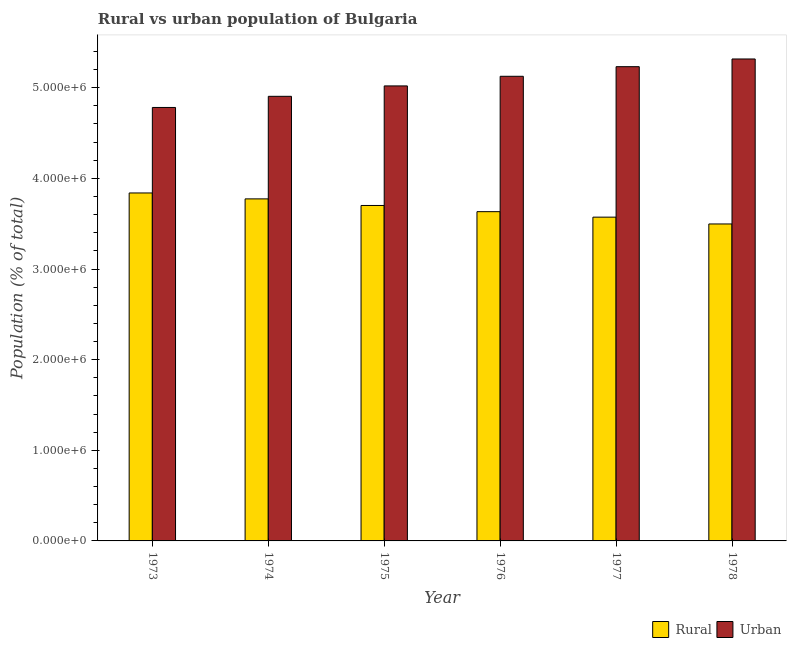How many different coloured bars are there?
Offer a terse response. 2. How many groups of bars are there?
Your answer should be compact. 6. Are the number of bars on each tick of the X-axis equal?
Provide a short and direct response. Yes. How many bars are there on the 6th tick from the left?
Give a very brief answer. 2. How many bars are there on the 2nd tick from the right?
Offer a very short reply. 2. What is the label of the 4th group of bars from the left?
Your answer should be compact. 1976. In how many cases, is the number of bars for a given year not equal to the number of legend labels?
Make the answer very short. 0. What is the urban population density in 1975?
Provide a short and direct response. 5.02e+06. Across all years, what is the maximum urban population density?
Offer a terse response. 5.32e+06. Across all years, what is the minimum urban population density?
Offer a very short reply. 4.78e+06. In which year was the urban population density maximum?
Your answer should be very brief. 1978. In which year was the rural population density minimum?
Your answer should be compact. 1978. What is the total rural population density in the graph?
Keep it short and to the point. 2.20e+07. What is the difference between the rural population density in 1974 and that in 1977?
Offer a terse response. 2.02e+05. What is the difference between the urban population density in 1977 and the rural population density in 1978?
Offer a terse response. -8.50e+04. What is the average urban population density per year?
Your answer should be very brief. 5.06e+06. In the year 1975, what is the difference between the urban population density and rural population density?
Your answer should be compact. 0. What is the ratio of the rural population density in 1975 to that in 1976?
Make the answer very short. 1.02. Is the urban population density in 1977 less than that in 1978?
Your answer should be compact. Yes. Is the difference between the rural population density in 1973 and 1974 greater than the difference between the urban population density in 1973 and 1974?
Provide a succinct answer. No. What is the difference between the highest and the second highest urban population density?
Give a very brief answer. 8.50e+04. What is the difference between the highest and the lowest urban population density?
Your answer should be compact. 5.35e+05. In how many years, is the urban population density greater than the average urban population density taken over all years?
Make the answer very short. 3. Is the sum of the urban population density in 1977 and 1978 greater than the maximum rural population density across all years?
Make the answer very short. Yes. What does the 2nd bar from the left in 1974 represents?
Ensure brevity in your answer.  Urban. What does the 1st bar from the right in 1977 represents?
Your response must be concise. Urban. Are all the bars in the graph horizontal?
Offer a very short reply. No. How many years are there in the graph?
Ensure brevity in your answer.  6. Are the values on the major ticks of Y-axis written in scientific E-notation?
Keep it short and to the point. Yes. Does the graph contain grids?
Give a very brief answer. No. How many legend labels are there?
Provide a short and direct response. 2. What is the title of the graph?
Make the answer very short. Rural vs urban population of Bulgaria. Does "Male entrants" appear as one of the legend labels in the graph?
Keep it short and to the point. No. What is the label or title of the X-axis?
Offer a very short reply. Year. What is the label or title of the Y-axis?
Your answer should be compact. Population (% of total). What is the Population (% of total) of Rural in 1973?
Ensure brevity in your answer.  3.84e+06. What is the Population (% of total) in Urban in 1973?
Offer a terse response. 4.78e+06. What is the Population (% of total) in Rural in 1974?
Your answer should be very brief. 3.77e+06. What is the Population (% of total) in Urban in 1974?
Your response must be concise. 4.91e+06. What is the Population (% of total) in Rural in 1975?
Give a very brief answer. 3.70e+06. What is the Population (% of total) of Urban in 1975?
Provide a succinct answer. 5.02e+06. What is the Population (% of total) in Rural in 1976?
Give a very brief answer. 3.63e+06. What is the Population (% of total) in Urban in 1976?
Your answer should be compact. 5.13e+06. What is the Population (% of total) of Rural in 1977?
Give a very brief answer. 3.57e+06. What is the Population (% of total) of Urban in 1977?
Offer a terse response. 5.23e+06. What is the Population (% of total) of Rural in 1978?
Make the answer very short. 3.50e+06. What is the Population (% of total) in Urban in 1978?
Ensure brevity in your answer.  5.32e+06. Across all years, what is the maximum Population (% of total) of Rural?
Make the answer very short. 3.84e+06. Across all years, what is the maximum Population (% of total) of Urban?
Offer a terse response. 5.32e+06. Across all years, what is the minimum Population (% of total) of Rural?
Provide a short and direct response. 3.50e+06. Across all years, what is the minimum Population (% of total) in Urban?
Provide a succinct answer. 4.78e+06. What is the total Population (% of total) of Rural in the graph?
Offer a terse response. 2.20e+07. What is the total Population (% of total) of Urban in the graph?
Your response must be concise. 3.04e+07. What is the difference between the Population (% of total) in Rural in 1973 and that in 1974?
Offer a terse response. 6.52e+04. What is the difference between the Population (% of total) of Urban in 1973 and that in 1974?
Your answer should be compact. -1.23e+05. What is the difference between the Population (% of total) of Rural in 1973 and that in 1975?
Your response must be concise. 1.38e+05. What is the difference between the Population (% of total) of Urban in 1973 and that in 1975?
Offer a terse response. -2.38e+05. What is the difference between the Population (% of total) in Rural in 1973 and that in 1976?
Your answer should be compact. 2.06e+05. What is the difference between the Population (% of total) of Urban in 1973 and that in 1976?
Your answer should be very brief. -3.44e+05. What is the difference between the Population (% of total) of Rural in 1973 and that in 1977?
Make the answer very short. 2.67e+05. What is the difference between the Population (% of total) in Urban in 1973 and that in 1977?
Keep it short and to the point. -4.50e+05. What is the difference between the Population (% of total) in Rural in 1973 and that in 1978?
Provide a succinct answer. 3.42e+05. What is the difference between the Population (% of total) of Urban in 1973 and that in 1978?
Keep it short and to the point. -5.35e+05. What is the difference between the Population (% of total) in Rural in 1974 and that in 1975?
Provide a short and direct response. 7.27e+04. What is the difference between the Population (% of total) of Urban in 1974 and that in 1975?
Offer a terse response. -1.15e+05. What is the difference between the Population (% of total) of Rural in 1974 and that in 1976?
Provide a short and direct response. 1.41e+05. What is the difference between the Population (% of total) in Urban in 1974 and that in 1976?
Your response must be concise. -2.21e+05. What is the difference between the Population (% of total) of Rural in 1974 and that in 1977?
Give a very brief answer. 2.02e+05. What is the difference between the Population (% of total) in Urban in 1974 and that in 1977?
Make the answer very short. -3.27e+05. What is the difference between the Population (% of total) of Rural in 1974 and that in 1978?
Offer a very short reply. 2.77e+05. What is the difference between the Population (% of total) in Urban in 1974 and that in 1978?
Offer a terse response. -4.12e+05. What is the difference between the Population (% of total) in Rural in 1975 and that in 1976?
Make the answer very short. 6.84e+04. What is the difference between the Population (% of total) of Urban in 1975 and that in 1976?
Your answer should be compact. -1.06e+05. What is the difference between the Population (% of total) of Rural in 1975 and that in 1977?
Provide a succinct answer. 1.29e+05. What is the difference between the Population (% of total) of Urban in 1975 and that in 1977?
Offer a terse response. -2.12e+05. What is the difference between the Population (% of total) in Rural in 1975 and that in 1978?
Provide a succinct answer. 2.04e+05. What is the difference between the Population (% of total) of Urban in 1975 and that in 1978?
Offer a very short reply. -2.97e+05. What is the difference between the Population (% of total) of Rural in 1976 and that in 1977?
Ensure brevity in your answer.  6.05e+04. What is the difference between the Population (% of total) of Urban in 1976 and that in 1977?
Give a very brief answer. -1.06e+05. What is the difference between the Population (% of total) in Rural in 1976 and that in 1978?
Give a very brief answer. 1.36e+05. What is the difference between the Population (% of total) in Urban in 1976 and that in 1978?
Your answer should be compact. -1.91e+05. What is the difference between the Population (% of total) in Rural in 1977 and that in 1978?
Your answer should be compact. 7.52e+04. What is the difference between the Population (% of total) in Urban in 1977 and that in 1978?
Give a very brief answer. -8.50e+04. What is the difference between the Population (% of total) of Rural in 1973 and the Population (% of total) of Urban in 1974?
Give a very brief answer. -1.07e+06. What is the difference between the Population (% of total) in Rural in 1973 and the Population (% of total) in Urban in 1975?
Offer a very short reply. -1.18e+06. What is the difference between the Population (% of total) in Rural in 1973 and the Population (% of total) in Urban in 1976?
Make the answer very short. -1.29e+06. What is the difference between the Population (% of total) in Rural in 1973 and the Population (% of total) in Urban in 1977?
Your answer should be compact. -1.39e+06. What is the difference between the Population (% of total) in Rural in 1973 and the Population (% of total) in Urban in 1978?
Offer a very short reply. -1.48e+06. What is the difference between the Population (% of total) in Rural in 1974 and the Population (% of total) in Urban in 1975?
Provide a succinct answer. -1.25e+06. What is the difference between the Population (% of total) in Rural in 1974 and the Population (% of total) in Urban in 1976?
Give a very brief answer. -1.35e+06. What is the difference between the Population (% of total) in Rural in 1974 and the Population (% of total) in Urban in 1977?
Your response must be concise. -1.46e+06. What is the difference between the Population (% of total) of Rural in 1974 and the Population (% of total) of Urban in 1978?
Your answer should be compact. -1.54e+06. What is the difference between the Population (% of total) of Rural in 1975 and the Population (% of total) of Urban in 1976?
Provide a succinct answer. -1.43e+06. What is the difference between the Population (% of total) in Rural in 1975 and the Population (% of total) in Urban in 1977?
Keep it short and to the point. -1.53e+06. What is the difference between the Population (% of total) of Rural in 1975 and the Population (% of total) of Urban in 1978?
Offer a very short reply. -1.62e+06. What is the difference between the Population (% of total) of Rural in 1976 and the Population (% of total) of Urban in 1977?
Ensure brevity in your answer.  -1.60e+06. What is the difference between the Population (% of total) in Rural in 1976 and the Population (% of total) in Urban in 1978?
Offer a very short reply. -1.68e+06. What is the difference between the Population (% of total) of Rural in 1977 and the Population (% of total) of Urban in 1978?
Offer a very short reply. -1.75e+06. What is the average Population (% of total) of Rural per year?
Give a very brief answer. 3.67e+06. What is the average Population (% of total) of Urban per year?
Make the answer very short. 5.06e+06. In the year 1973, what is the difference between the Population (% of total) in Rural and Population (% of total) in Urban?
Your response must be concise. -9.43e+05. In the year 1974, what is the difference between the Population (% of total) of Rural and Population (% of total) of Urban?
Give a very brief answer. -1.13e+06. In the year 1975, what is the difference between the Population (% of total) in Rural and Population (% of total) in Urban?
Your response must be concise. -1.32e+06. In the year 1976, what is the difference between the Population (% of total) in Rural and Population (% of total) in Urban?
Your answer should be very brief. -1.49e+06. In the year 1977, what is the difference between the Population (% of total) in Rural and Population (% of total) in Urban?
Keep it short and to the point. -1.66e+06. In the year 1978, what is the difference between the Population (% of total) of Rural and Population (% of total) of Urban?
Your response must be concise. -1.82e+06. What is the ratio of the Population (% of total) of Rural in 1973 to that in 1974?
Your answer should be compact. 1.02. What is the ratio of the Population (% of total) in Urban in 1973 to that in 1974?
Make the answer very short. 0.97. What is the ratio of the Population (% of total) of Rural in 1973 to that in 1975?
Your answer should be very brief. 1.04. What is the ratio of the Population (% of total) of Urban in 1973 to that in 1975?
Provide a short and direct response. 0.95. What is the ratio of the Population (% of total) in Rural in 1973 to that in 1976?
Keep it short and to the point. 1.06. What is the ratio of the Population (% of total) of Urban in 1973 to that in 1976?
Provide a succinct answer. 0.93. What is the ratio of the Population (% of total) of Rural in 1973 to that in 1977?
Offer a very short reply. 1.07. What is the ratio of the Population (% of total) of Urban in 1973 to that in 1977?
Offer a terse response. 0.91. What is the ratio of the Population (% of total) in Rural in 1973 to that in 1978?
Offer a terse response. 1.1. What is the ratio of the Population (% of total) in Urban in 1973 to that in 1978?
Give a very brief answer. 0.9. What is the ratio of the Population (% of total) in Rural in 1974 to that in 1975?
Give a very brief answer. 1.02. What is the ratio of the Population (% of total) in Urban in 1974 to that in 1975?
Your answer should be compact. 0.98. What is the ratio of the Population (% of total) of Rural in 1974 to that in 1976?
Ensure brevity in your answer.  1.04. What is the ratio of the Population (% of total) of Urban in 1974 to that in 1976?
Ensure brevity in your answer.  0.96. What is the ratio of the Population (% of total) of Rural in 1974 to that in 1977?
Your response must be concise. 1.06. What is the ratio of the Population (% of total) of Urban in 1974 to that in 1977?
Provide a succinct answer. 0.94. What is the ratio of the Population (% of total) of Rural in 1974 to that in 1978?
Keep it short and to the point. 1.08. What is the ratio of the Population (% of total) of Urban in 1974 to that in 1978?
Provide a succinct answer. 0.92. What is the ratio of the Population (% of total) of Rural in 1975 to that in 1976?
Your response must be concise. 1.02. What is the ratio of the Population (% of total) in Urban in 1975 to that in 1976?
Give a very brief answer. 0.98. What is the ratio of the Population (% of total) of Rural in 1975 to that in 1977?
Provide a succinct answer. 1.04. What is the ratio of the Population (% of total) of Urban in 1975 to that in 1977?
Keep it short and to the point. 0.96. What is the ratio of the Population (% of total) of Rural in 1975 to that in 1978?
Provide a succinct answer. 1.06. What is the ratio of the Population (% of total) in Urban in 1975 to that in 1978?
Offer a terse response. 0.94. What is the ratio of the Population (% of total) of Rural in 1976 to that in 1977?
Give a very brief answer. 1.02. What is the ratio of the Population (% of total) of Urban in 1976 to that in 1977?
Offer a very short reply. 0.98. What is the ratio of the Population (% of total) of Rural in 1976 to that in 1978?
Offer a terse response. 1.04. What is the ratio of the Population (% of total) of Urban in 1976 to that in 1978?
Provide a short and direct response. 0.96. What is the ratio of the Population (% of total) in Rural in 1977 to that in 1978?
Keep it short and to the point. 1.02. What is the difference between the highest and the second highest Population (% of total) of Rural?
Provide a short and direct response. 6.52e+04. What is the difference between the highest and the second highest Population (% of total) in Urban?
Your response must be concise. 8.50e+04. What is the difference between the highest and the lowest Population (% of total) of Rural?
Ensure brevity in your answer.  3.42e+05. What is the difference between the highest and the lowest Population (% of total) in Urban?
Keep it short and to the point. 5.35e+05. 